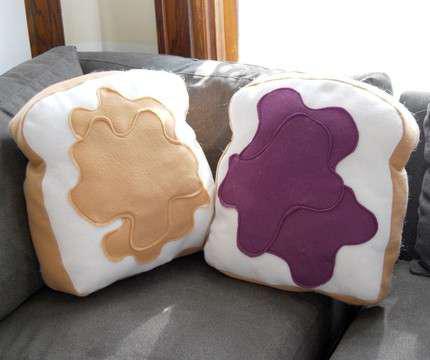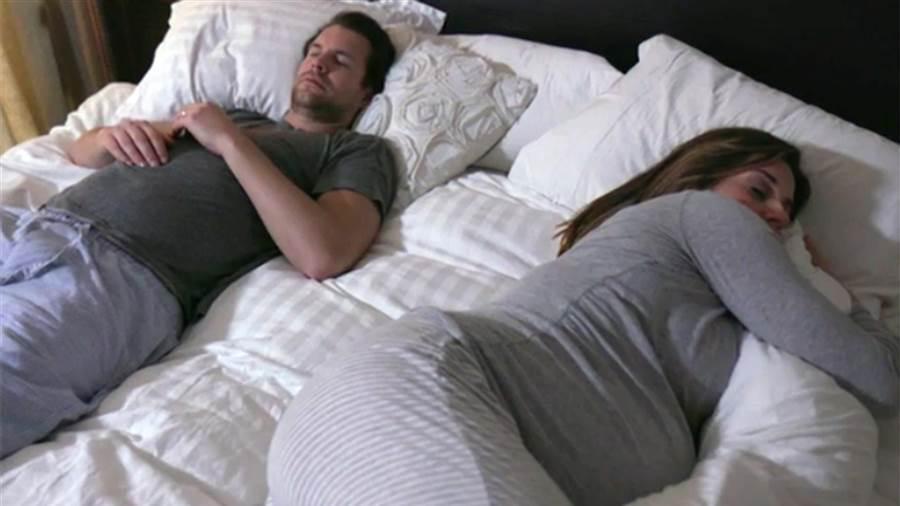The first image is the image on the left, the second image is the image on the right. Given the left and right images, does the statement "In one of the images there is just one person lying in bed with multiple pillows." hold true? Answer yes or no. No. 